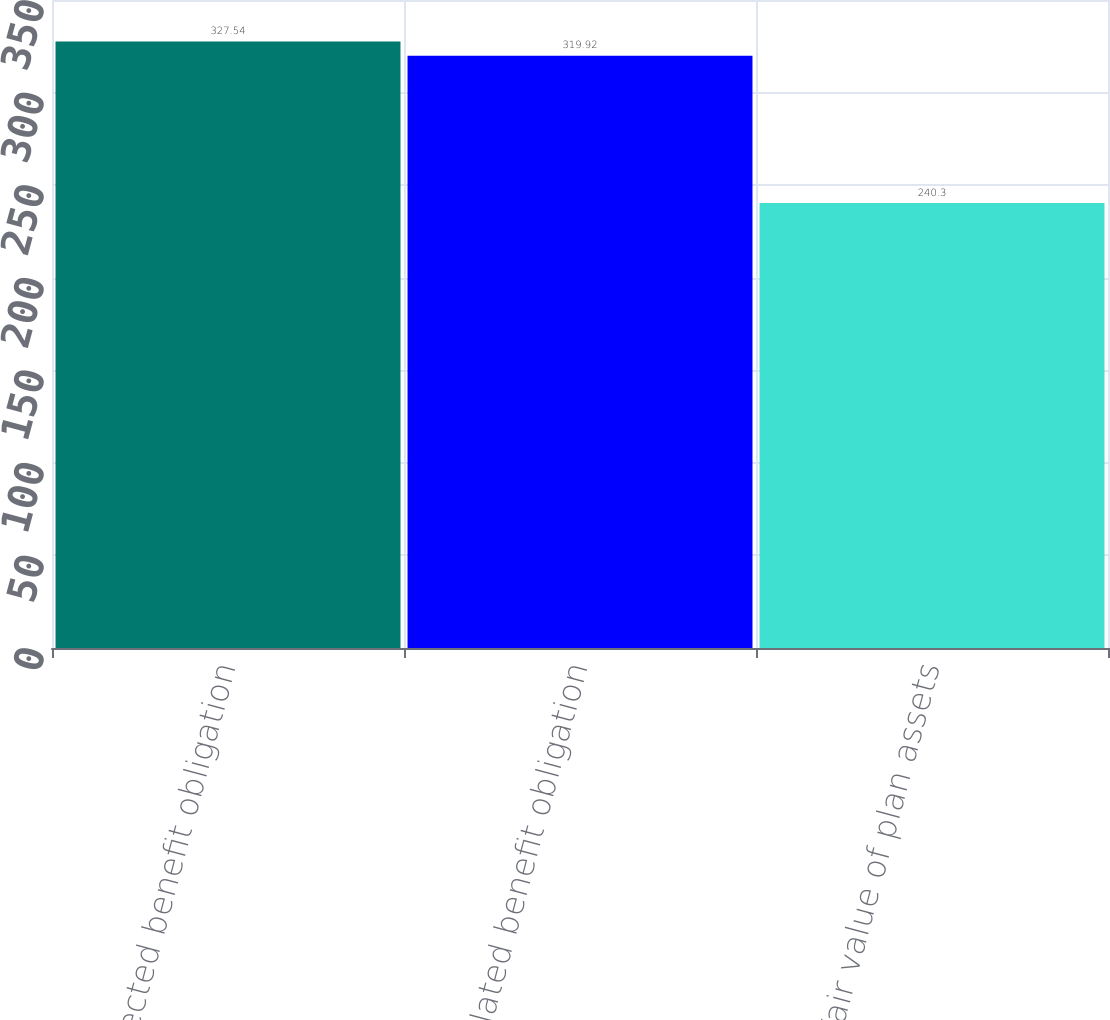Convert chart. <chart><loc_0><loc_0><loc_500><loc_500><bar_chart><fcel>Projected benefit obligation<fcel>Accumulated benefit obligation<fcel>Fair value of plan assets<nl><fcel>327.54<fcel>319.92<fcel>240.3<nl></chart> 